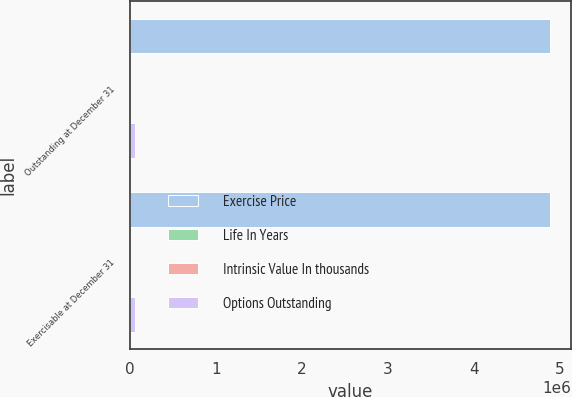Convert chart to OTSL. <chart><loc_0><loc_0><loc_500><loc_500><stacked_bar_chart><ecel><fcel>Outstanding at December 31<fcel>Exercisable at December 31<nl><fcel>Exercise Price<fcel>4.88076e+06<fcel>4.87915e+06<nl><fcel>Life In Years<fcel>105.48<fcel>105.49<nl><fcel>Intrinsic Value In thousands<fcel>2.8<fcel>2.8<nl><fcel>Options Outstanding<fcel>66464<fcel>66400<nl></chart> 